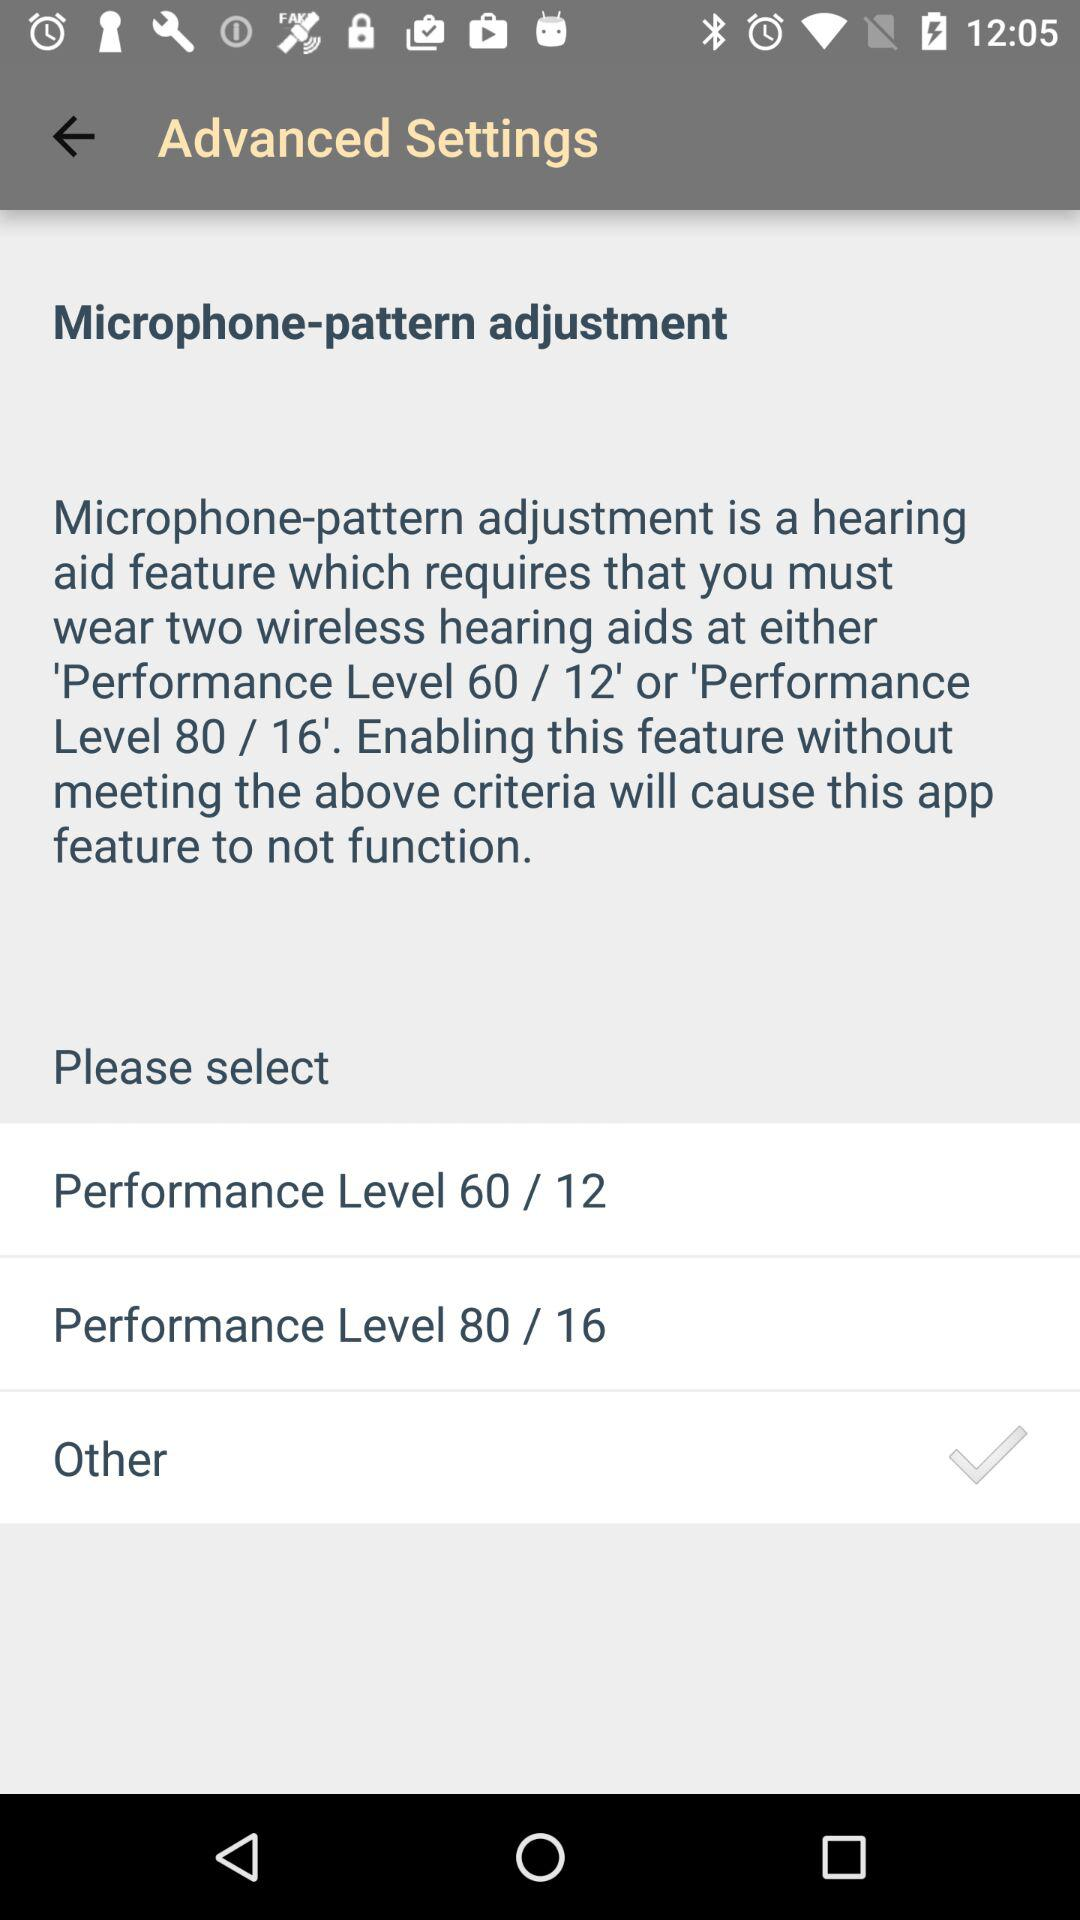What is the selected option? The selected option is "Other". 